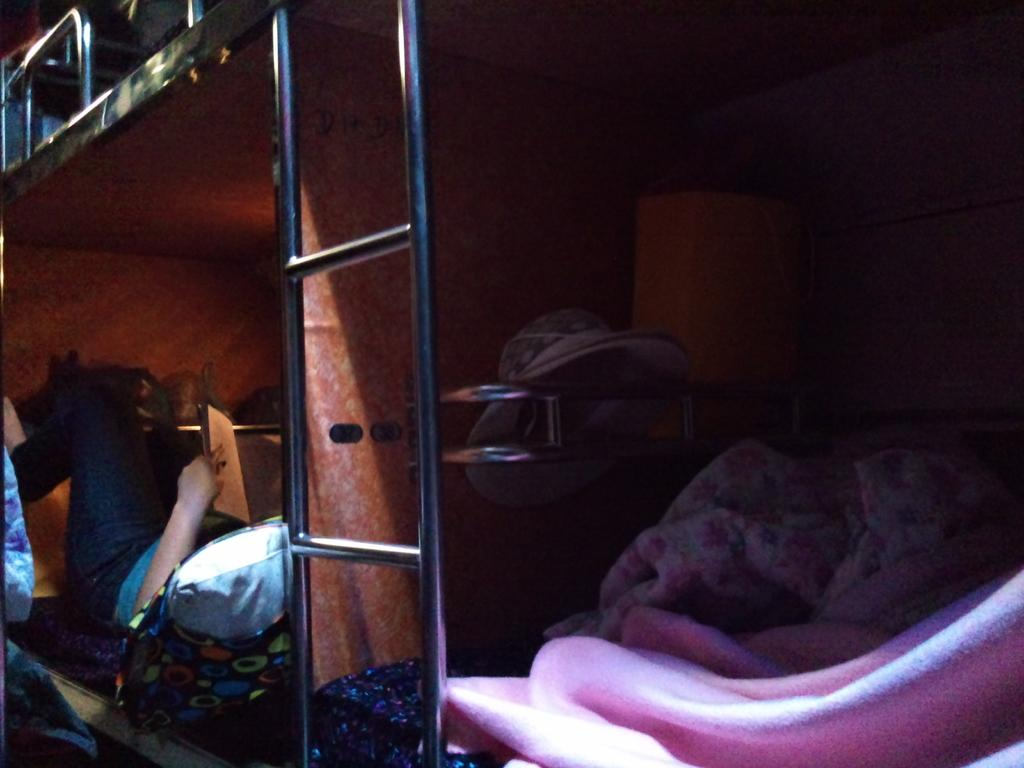What is the person in the bed doing? The person is sleeping in the bed. What object is the person holding while sleeping? The person is holding a book in their hand. What type of material can be seen near the bed? There are metal rods in the vicinity of the bed. How many other beds are visible in the image? There are other beds with blankets and other stuff nearby. What type of truck is parked on top of the bed? There is no truck present in the image; it only shows a person sleeping in the bed with a book and metal rods nearby. 